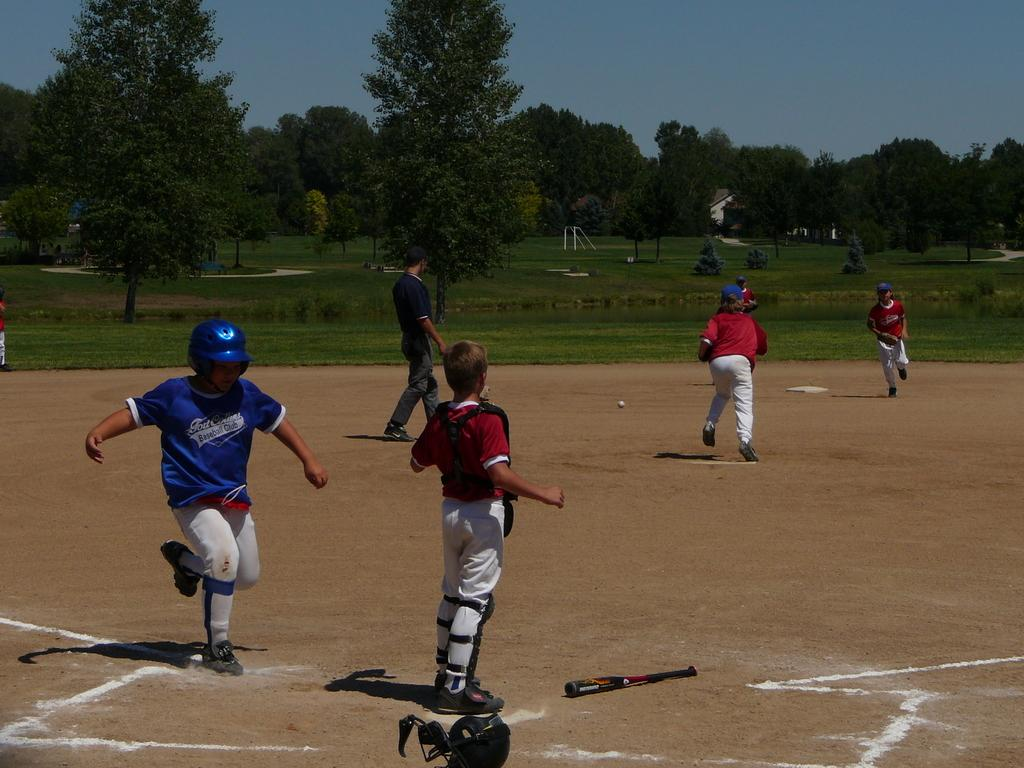<image>
Render a clear and concise summary of the photo. The kid in the blue uniform is part of a baseball club. 